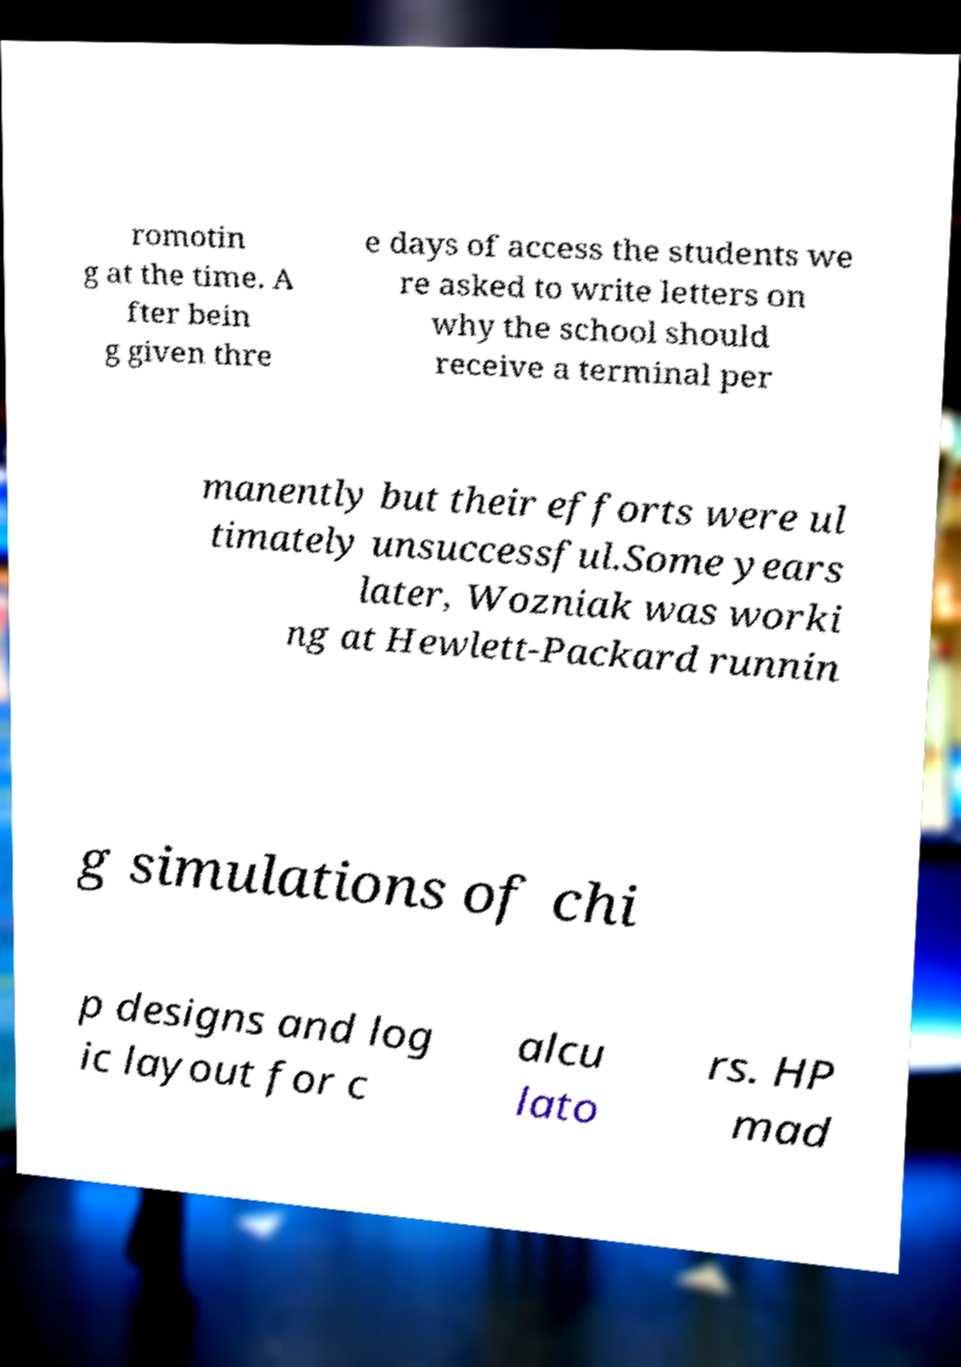Please read and relay the text visible in this image. What does it say? romotin g at the time. A fter bein g given thre e days of access the students we re asked to write letters on why the school should receive a terminal per manently but their efforts were ul timately unsuccessful.Some years later, Wozniak was worki ng at Hewlett-Packard runnin g simulations of chi p designs and log ic layout for c alcu lato rs. HP mad 